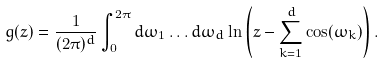<formula> <loc_0><loc_0><loc_500><loc_500>g ( z ) = \frac { 1 } { ( 2 \pi ) ^ { d } } \int _ { 0 } ^ { 2 \pi } d \omega _ { 1 } \dots d \omega _ { d } \ln \left ( z - \sum _ { k = 1 } ^ { d } \cos ( \omega _ { k } ) \right ) .</formula> 